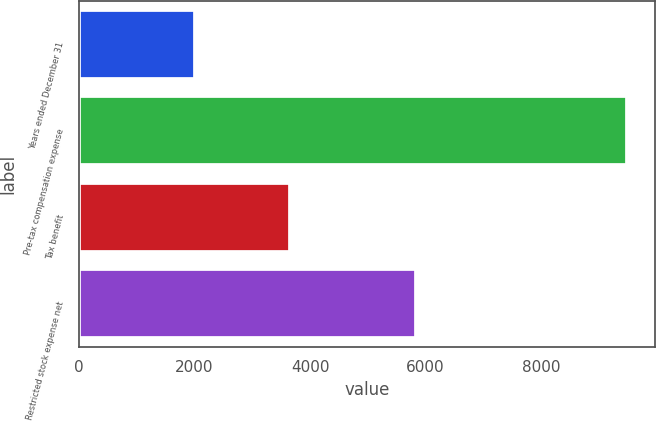<chart> <loc_0><loc_0><loc_500><loc_500><bar_chart><fcel>Years ended December 31<fcel>Pre-tax compensation expense<fcel>Tax benefit<fcel>Restricted stock expense net<nl><fcel>2012<fcel>9494<fcel>3655<fcel>5839<nl></chart> 